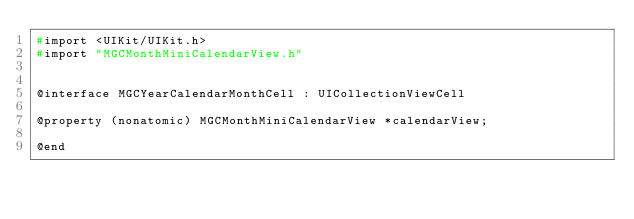Convert code to text. <code><loc_0><loc_0><loc_500><loc_500><_C_>#import <UIKit/UIKit.h>
#import "MGCMonthMiniCalendarView.h"


@interface MGCYearCalendarMonthCell : UICollectionViewCell

@property (nonatomic) MGCMonthMiniCalendarView *calendarView;

@end
</code> 